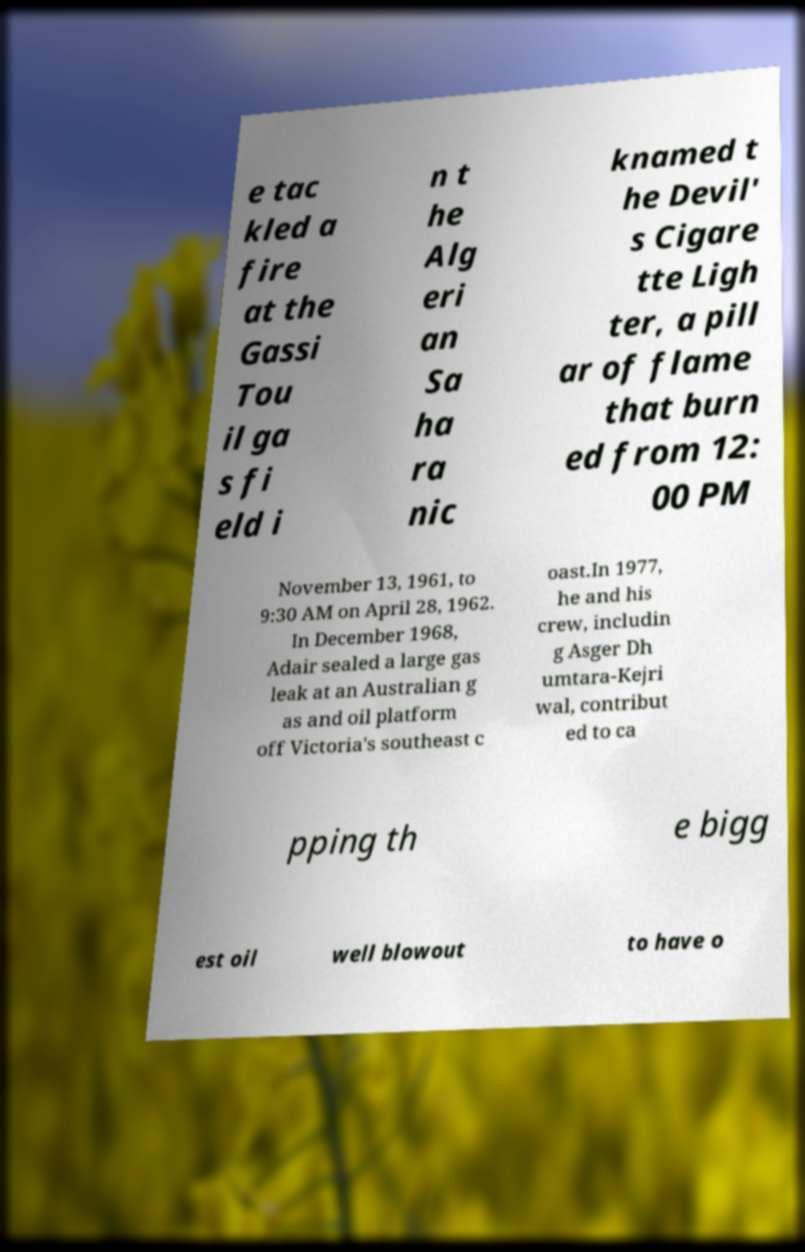I need the written content from this picture converted into text. Can you do that? e tac kled a fire at the Gassi Tou il ga s fi eld i n t he Alg eri an Sa ha ra nic knamed t he Devil' s Cigare tte Ligh ter, a pill ar of flame that burn ed from 12: 00 PM November 13, 1961, to 9:30 AM on April 28, 1962. In December 1968, Adair sealed a large gas leak at an Australian g as and oil platform off Victoria's southeast c oast.In 1977, he and his crew, includin g Asger Dh umtara-Kejri wal, contribut ed to ca pping th e bigg est oil well blowout to have o 